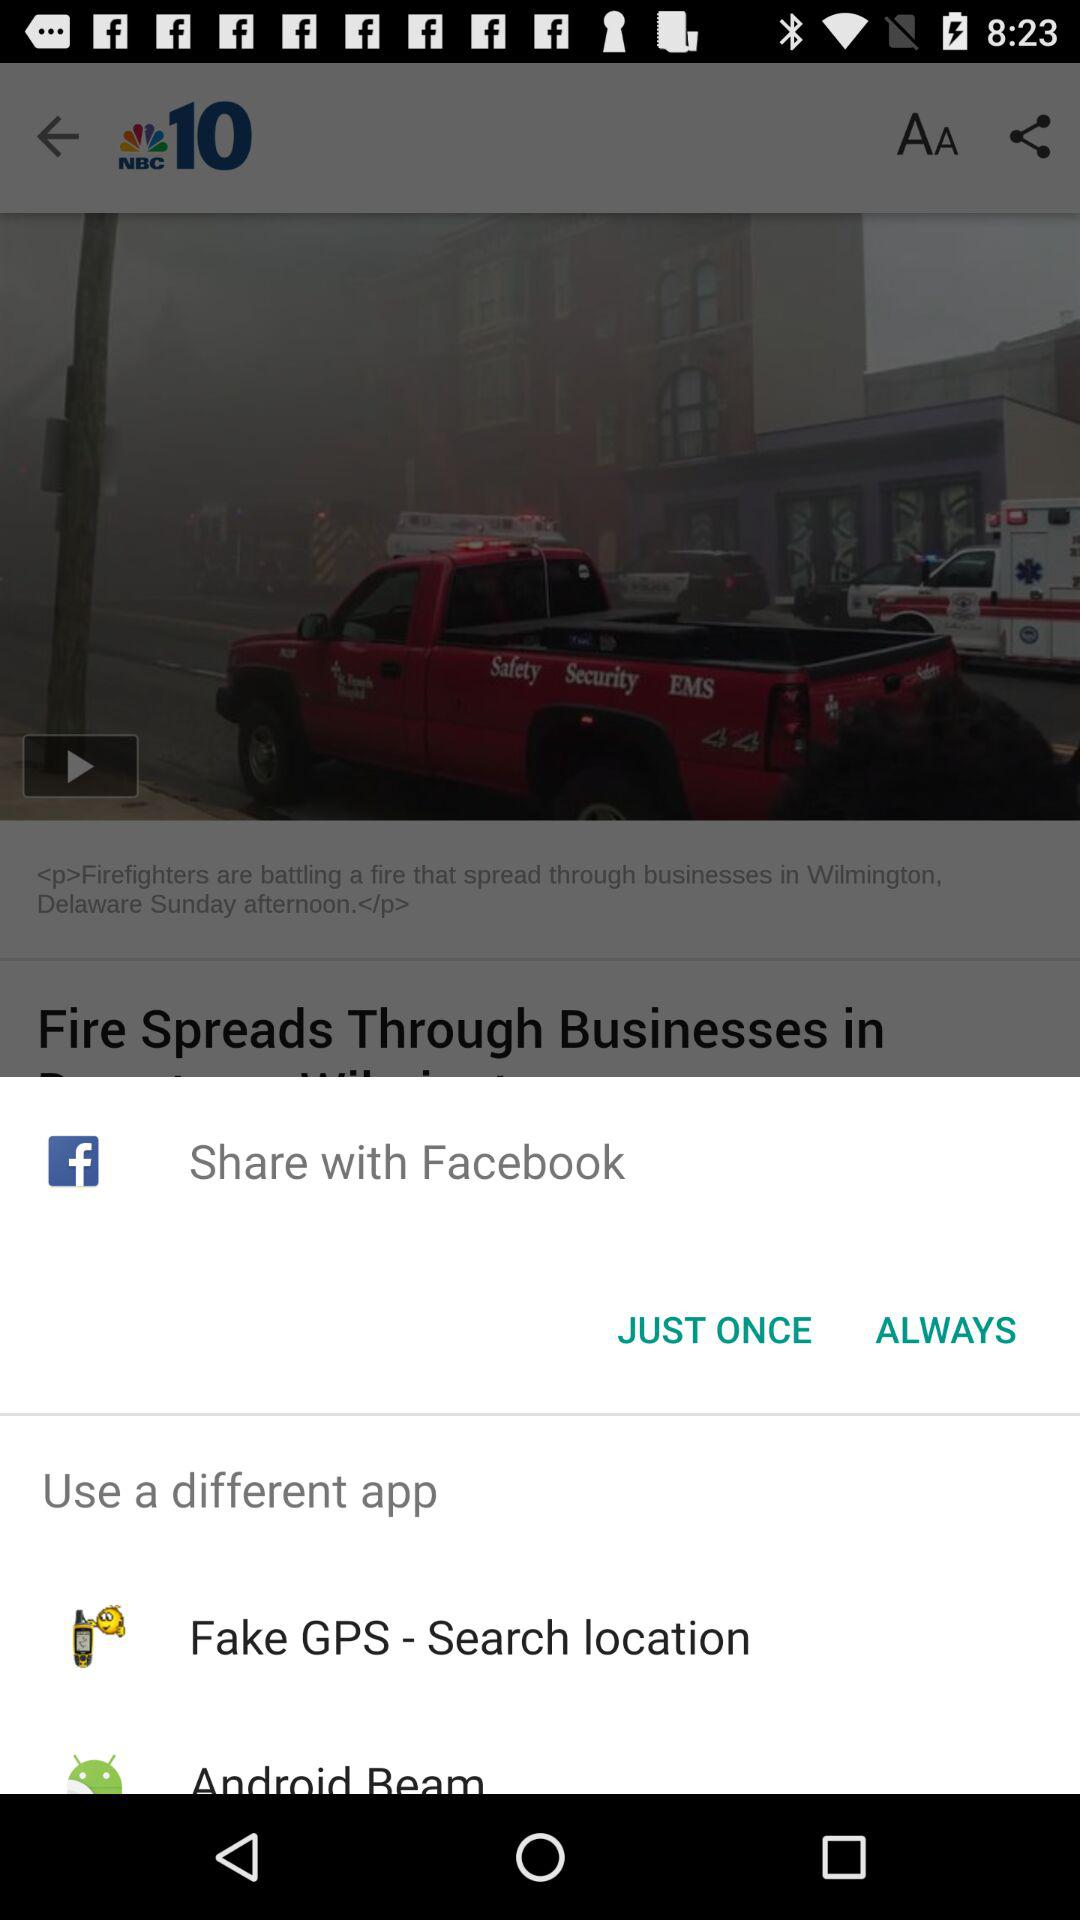What are the different available apps? The different available apps are "NBC 10", "Facebook", "Fake GPS - Search location" and "Android Beam". 